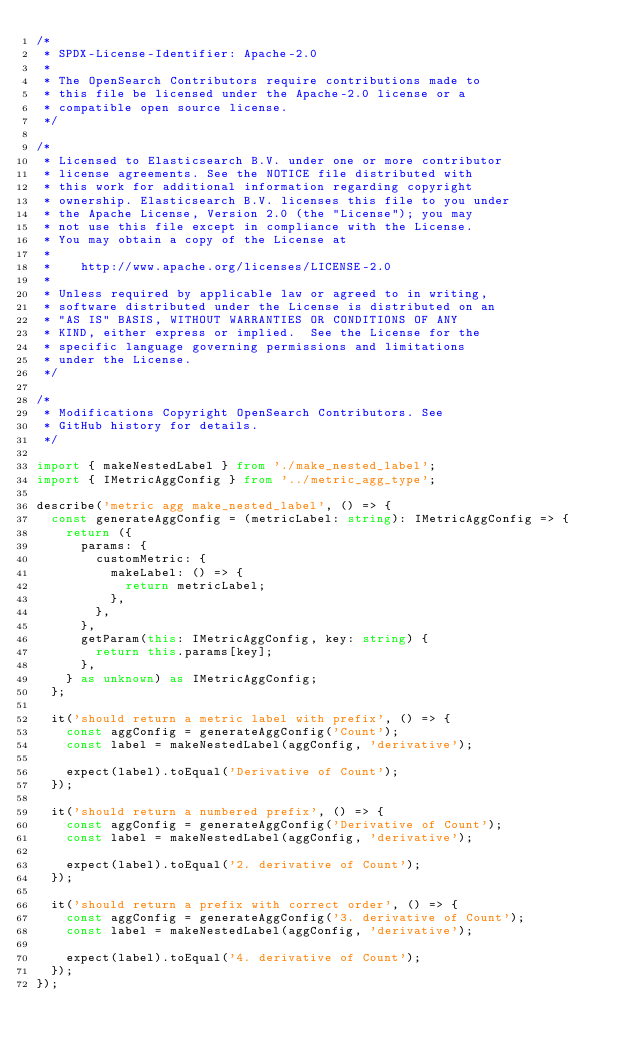Convert code to text. <code><loc_0><loc_0><loc_500><loc_500><_TypeScript_>/*
 * SPDX-License-Identifier: Apache-2.0
 *
 * The OpenSearch Contributors require contributions made to
 * this file be licensed under the Apache-2.0 license or a
 * compatible open source license.
 */

/*
 * Licensed to Elasticsearch B.V. under one or more contributor
 * license agreements. See the NOTICE file distributed with
 * this work for additional information regarding copyright
 * ownership. Elasticsearch B.V. licenses this file to you under
 * the Apache License, Version 2.0 (the "License"); you may
 * not use this file except in compliance with the License.
 * You may obtain a copy of the License at
 *
 *    http://www.apache.org/licenses/LICENSE-2.0
 *
 * Unless required by applicable law or agreed to in writing,
 * software distributed under the License is distributed on an
 * "AS IS" BASIS, WITHOUT WARRANTIES OR CONDITIONS OF ANY
 * KIND, either express or implied.  See the License for the
 * specific language governing permissions and limitations
 * under the License.
 */

/*
 * Modifications Copyright OpenSearch Contributors. See
 * GitHub history for details.
 */

import { makeNestedLabel } from './make_nested_label';
import { IMetricAggConfig } from '../metric_agg_type';

describe('metric agg make_nested_label', () => {
  const generateAggConfig = (metricLabel: string): IMetricAggConfig => {
    return ({
      params: {
        customMetric: {
          makeLabel: () => {
            return metricLabel;
          },
        },
      },
      getParam(this: IMetricAggConfig, key: string) {
        return this.params[key];
      },
    } as unknown) as IMetricAggConfig;
  };

  it('should return a metric label with prefix', () => {
    const aggConfig = generateAggConfig('Count');
    const label = makeNestedLabel(aggConfig, 'derivative');

    expect(label).toEqual('Derivative of Count');
  });

  it('should return a numbered prefix', () => {
    const aggConfig = generateAggConfig('Derivative of Count');
    const label = makeNestedLabel(aggConfig, 'derivative');

    expect(label).toEqual('2. derivative of Count');
  });

  it('should return a prefix with correct order', () => {
    const aggConfig = generateAggConfig('3. derivative of Count');
    const label = makeNestedLabel(aggConfig, 'derivative');

    expect(label).toEqual('4. derivative of Count');
  });
});
</code> 